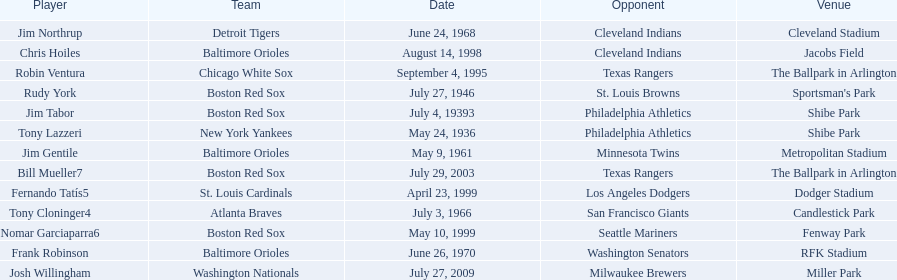What are the names of all the players? Tony Lazzeri, Jim Tabor, Rudy York, Jim Gentile, Tony Cloninger4, Jim Northrup, Frank Robinson, Robin Ventura, Chris Hoiles, Fernando Tatís5, Nomar Garciaparra6, Bill Mueller7, Josh Willingham. What are the names of all the teams holding home run records? New York Yankees, Boston Red Sox, Baltimore Orioles, Atlanta Braves, Detroit Tigers, Chicago White Sox, St. Louis Cardinals, Washington Nationals. Which player played for the new york yankees? Tony Lazzeri. 